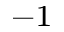<formula> <loc_0><loc_0><loc_500><loc_500>^ { - 1 }</formula> 